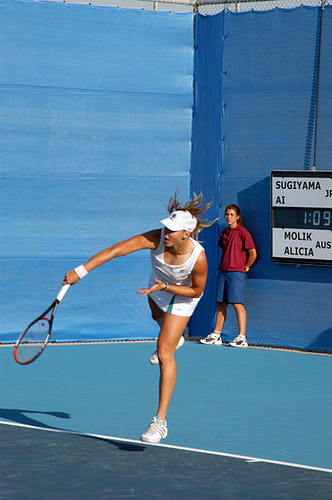<image>Where is the woman playing? I don't know where the woman is playing. It could be at a tennis court. Where is the woman playing? The woman is playing tennis on the tennis court. 